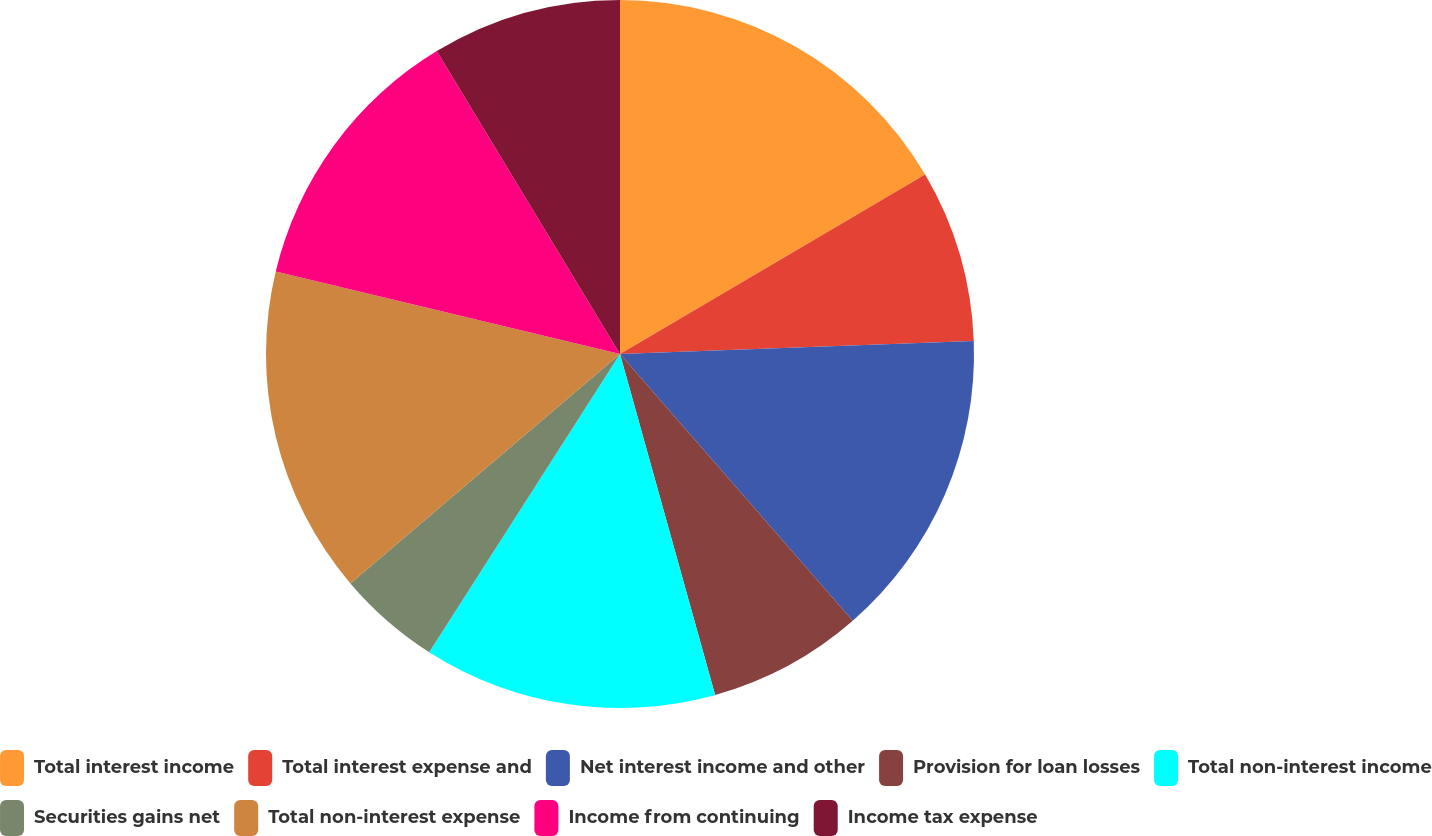<chart> <loc_0><loc_0><loc_500><loc_500><pie_chart><fcel>Total interest income<fcel>Total interest expense and<fcel>Net interest income and other<fcel>Provision for loan losses<fcel>Total non-interest income<fcel>Securities gains net<fcel>Total non-interest expense<fcel>Income from continuing<fcel>Income tax expense<nl><fcel>16.54%<fcel>7.87%<fcel>14.17%<fcel>7.09%<fcel>13.39%<fcel>4.72%<fcel>14.96%<fcel>12.6%<fcel>8.66%<nl></chart> 